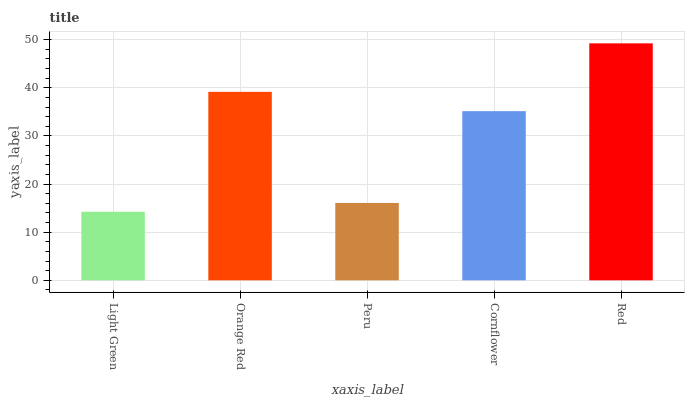Is Light Green the minimum?
Answer yes or no. Yes. Is Red the maximum?
Answer yes or no. Yes. Is Orange Red the minimum?
Answer yes or no. No. Is Orange Red the maximum?
Answer yes or no. No. Is Orange Red greater than Light Green?
Answer yes or no. Yes. Is Light Green less than Orange Red?
Answer yes or no. Yes. Is Light Green greater than Orange Red?
Answer yes or no. No. Is Orange Red less than Light Green?
Answer yes or no. No. Is Cornflower the high median?
Answer yes or no. Yes. Is Cornflower the low median?
Answer yes or no. Yes. Is Peru the high median?
Answer yes or no. No. Is Peru the low median?
Answer yes or no. No. 